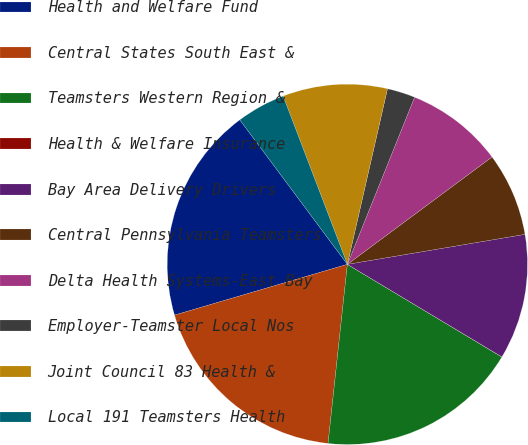Convert chart to OTSL. <chart><loc_0><loc_0><loc_500><loc_500><pie_chart><fcel>Health and Welfare Fund<fcel>Central States South East &<fcel>Teamsters Western Region &<fcel>Health & Welfare Insurance<fcel>Bay Area Delivery Drivers<fcel>Central Pennsylvania Teamsters<fcel>Delta Health Systems-East Bay<fcel>Employer-Teamster Local Nos<fcel>Joint Council 83 Health &<fcel>Local 191 Teamsters Health<nl><fcel>19.36%<fcel>18.74%<fcel>18.11%<fcel>0.01%<fcel>11.25%<fcel>7.5%<fcel>8.75%<fcel>2.51%<fcel>9.38%<fcel>4.38%<nl></chart> 